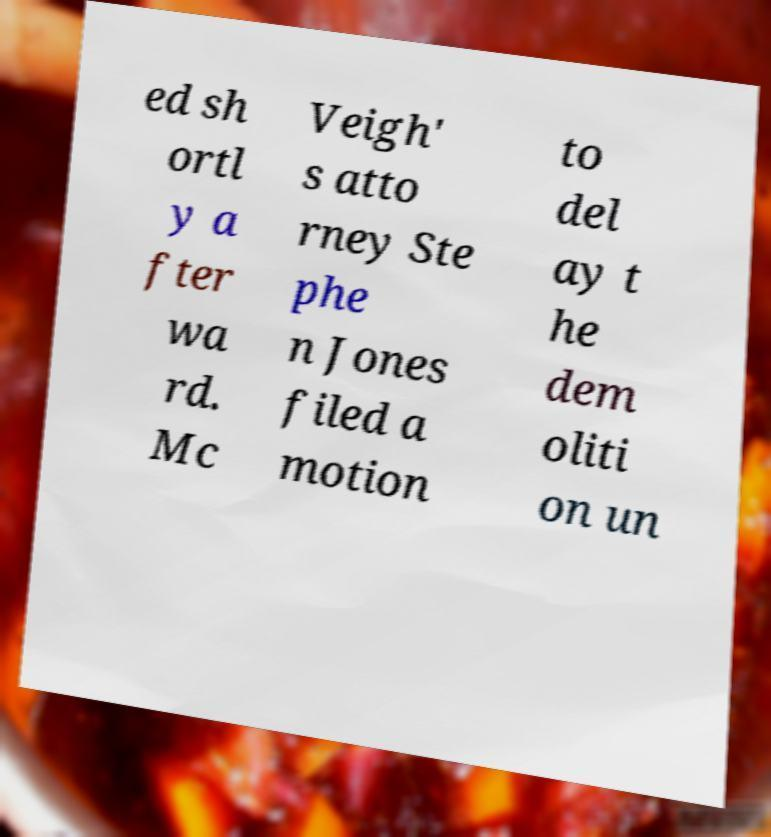Can you read and provide the text displayed in the image?This photo seems to have some interesting text. Can you extract and type it out for me? ed sh ortl y a fter wa rd. Mc Veigh' s atto rney Ste phe n Jones filed a motion to del ay t he dem oliti on un 